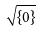Convert formula to latex. <formula><loc_0><loc_0><loc_500><loc_500>\sqrt { \{ 0 \} }</formula> 